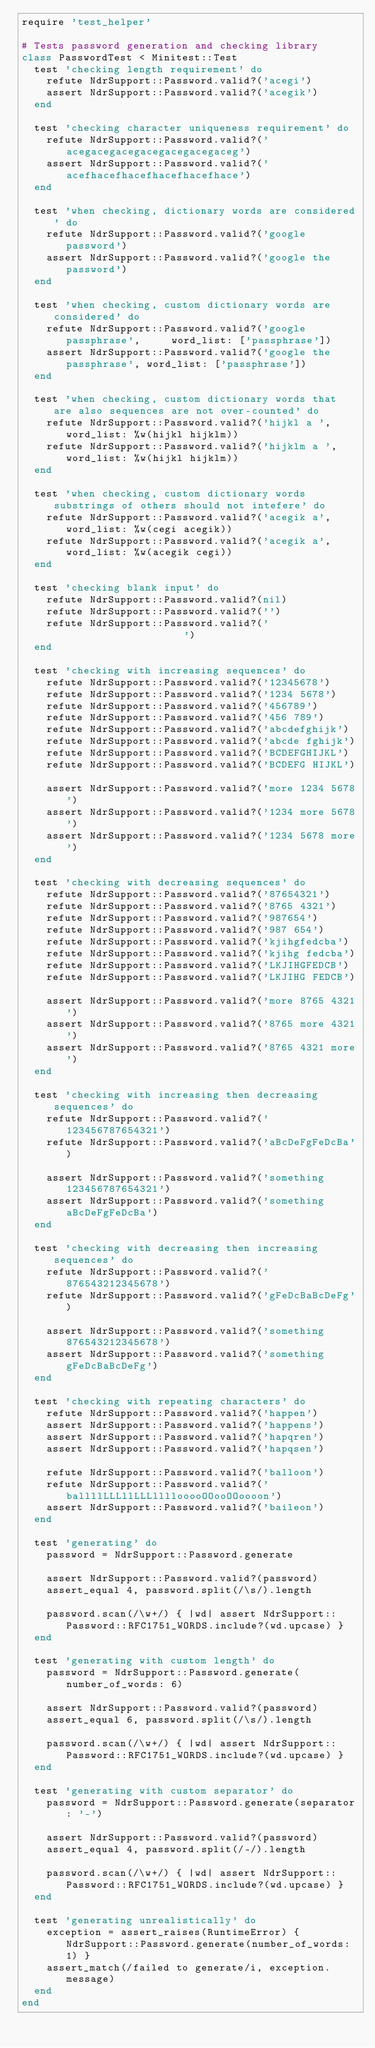Convert code to text. <code><loc_0><loc_0><loc_500><loc_500><_Ruby_>require 'test_helper'

# Tests password generation and checking library
class PasswordTest < Minitest::Test
  test 'checking length requirement' do
    refute NdrSupport::Password.valid?('acegi')
    assert NdrSupport::Password.valid?('acegik')
  end

  test 'checking character uniqueness requirement' do
    refute NdrSupport::Password.valid?('acegacegacegacegacegacegaceg')
    assert NdrSupport::Password.valid?('acefhacefhacefhacefhacefhace')
  end

  test 'when checking, dictionary words are considered' do
    refute NdrSupport::Password.valid?('google password')
    assert NdrSupport::Password.valid?('google the password')
  end

  test 'when checking, custom dictionary words are considered' do
    refute NdrSupport::Password.valid?('google passphrase',     word_list: ['passphrase'])
    assert NdrSupport::Password.valid?('google the passphrase', word_list: ['passphrase'])
  end

  test 'when checking, custom dictionary words that are also sequences are not over-counted' do
    refute NdrSupport::Password.valid?('hijkl a ',  word_list: %w(hijkl hijklm))
    refute NdrSupport::Password.valid?('hijklm a ', word_list: %w(hijkl hijklm))
  end

  test 'when checking, custom dictionary words substrings of others should not intefere' do
    refute NdrSupport::Password.valid?('acegik a', word_list: %w(cegi acegik))
    refute NdrSupport::Password.valid?('acegik a', word_list: %w(acegik cegi))
  end

  test 'checking blank input' do
    refute NdrSupport::Password.valid?(nil)
    refute NdrSupport::Password.valid?('')
    refute NdrSupport::Password.valid?('                    ')
  end

  test 'checking with increasing sequences' do
    refute NdrSupport::Password.valid?('12345678')
    refute NdrSupport::Password.valid?('1234 5678')
    refute NdrSupport::Password.valid?('456789')
    refute NdrSupport::Password.valid?('456 789')
    refute NdrSupport::Password.valid?('abcdefghijk')
    refute NdrSupport::Password.valid?('abcde fghijk')
    refute NdrSupport::Password.valid?('BCDEFGHIJKL')
    refute NdrSupport::Password.valid?('BCDEFG HIJKL')

    assert NdrSupport::Password.valid?('more 1234 5678')
    assert NdrSupport::Password.valid?('1234 more 5678')
    assert NdrSupport::Password.valid?('1234 5678 more')
  end

  test 'checking with decreasing sequences' do
    refute NdrSupport::Password.valid?('87654321')
    refute NdrSupport::Password.valid?('8765 4321')
    refute NdrSupport::Password.valid?('987654')
    refute NdrSupport::Password.valid?('987 654')
    refute NdrSupport::Password.valid?('kjihgfedcba')
    refute NdrSupport::Password.valid?('kjihg fedcba')
    refute NdrSupport::Password.valid?('LKJIHGFEDCB')
    refute NdrSupport::Password.valid?('LKJIHG FEDCB')

    assert NdrSupport::Password.valid?('more 8765 4321')
    assert NdrSupport::Password.valid?('8765 more 4321')
    assert NdrSupport::Password.valid?('8765 4321 more')
  end

  test 'checking with increasing then decreasing sequences' do
    refute NdrSupport::Password.valid?('123456787654321')
    refute NdrSupport::Password.valid?('aBcDeFgFeDcBa')

    assert NdrSupport::Password.valid?('something 123456787654321')
    assert NdrSupport::Password.valid?('something aBcDeFgFeDcBa')
  end

  test 'checking with decreasing then increasing sequences' do
    refute NdrSupport::Password.valid?('876543212345678')
    refute NdrSupport::Password.valid?('gFeDcBaBcDeFg')

    assert NdrSupport::Password.valid?('something 876543212345678')
    assert NdrSupport::Password.valid?('something gFeDcBaBcDeFg')
  end

  test 'checking with repeating characters' do
    refute NdrSupport::Password.valid?('happen')
    assert NdrSupport::Password.valid?('happens')
    assert NdrSupport::Password.valid?('hapqren')
    assert NdrSupport::Password.valid?('hapqsen')

    refute NdrSupport::Password.valid?('balloon')
    refute NdrSupport::Password.valid?('ballllLLLllLLLllllooooOOooOOoooon')
    assert NdrSupport::Password.valid?('baileon')
  end

  test 'generating' do
    password = NdrSupport::Password.generate

    assert NdrSupport::Password.valid?(password)
    assert_equal 4, password.split(/\s/).length

    password.scan(/\w+/) { |wd| assert NdrSupport::Password::RFC1751_WORDS.include?(wd.upcase) }
  end

  test 'generating with custom length' do
    password = NdrSupport::Password.generate(number_of_words: 6)

    assert NdrSupport::Password.valid?(password)
    assert_equal 6, password.split(/\s/).length

    password.scan(/\w+/) { |wd| assert NdrSupport::Password::RFC1751_WORDS.include?(wd.upcase) }
  end

  test 'generating with custom separator' do
    password = NdrSupport::Password.generate(separator: '-')

    assert NdrSupport::Password.valid?(password)
    assert_equal 4, password.split(/-/).length

    password.scan(/\w+/) { |wd| assert NdrSupport::Password::RFC1751_WORDS.include?(wd.upcase) }
  end

  test 'generating unrealistically' do
    exception = assert_raises(RuntimeError) { NdrSupport::Password.generate(number_of_words: 1) }
    assert_match(/failed to generate/i, exception.message)
  end
end
</code> 